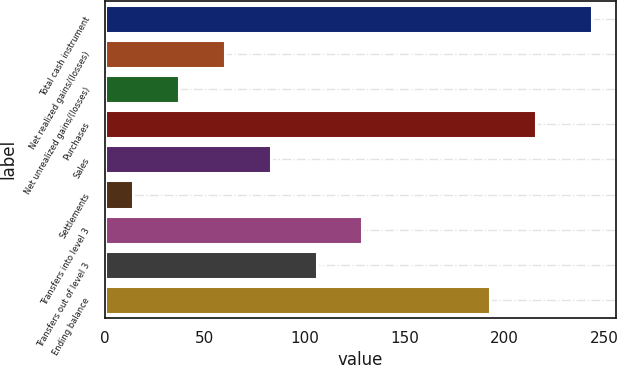Convert chart. <chart><loc_0><loc_0><loc_500><loc_500><bar_chart><fcel>Total cash instrument<fcel>Net realized gains/(losses)<fcel>Net unrealized gains/(losses)<fcel>Purchases<fcel>Sales<fcel>Settlements<fcel>Transfers into level 3<fcel>Transfers out of level 3<fcel>Ending balance<nl><fcel>244<fcel>60<fcel>37<fcel>216<fcel>83<fcel>14<fcel>129<fcel>106<fcel>193<nl></chart> 